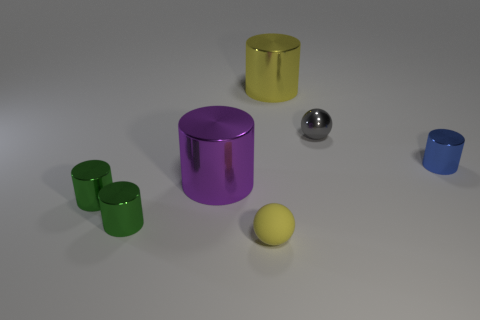Compare the size of the green cylinders to that of the sphere. The green cylinders are taller and wider than the small silver sphere. There are three different sizes of green cylinders, with the largest being approximately twice the height of the sphere.  Are there any patterns or logos on the objects? No, the objects do not feature any visible patterns, logos, or text. Their surfaces are uniform in color and texture. 